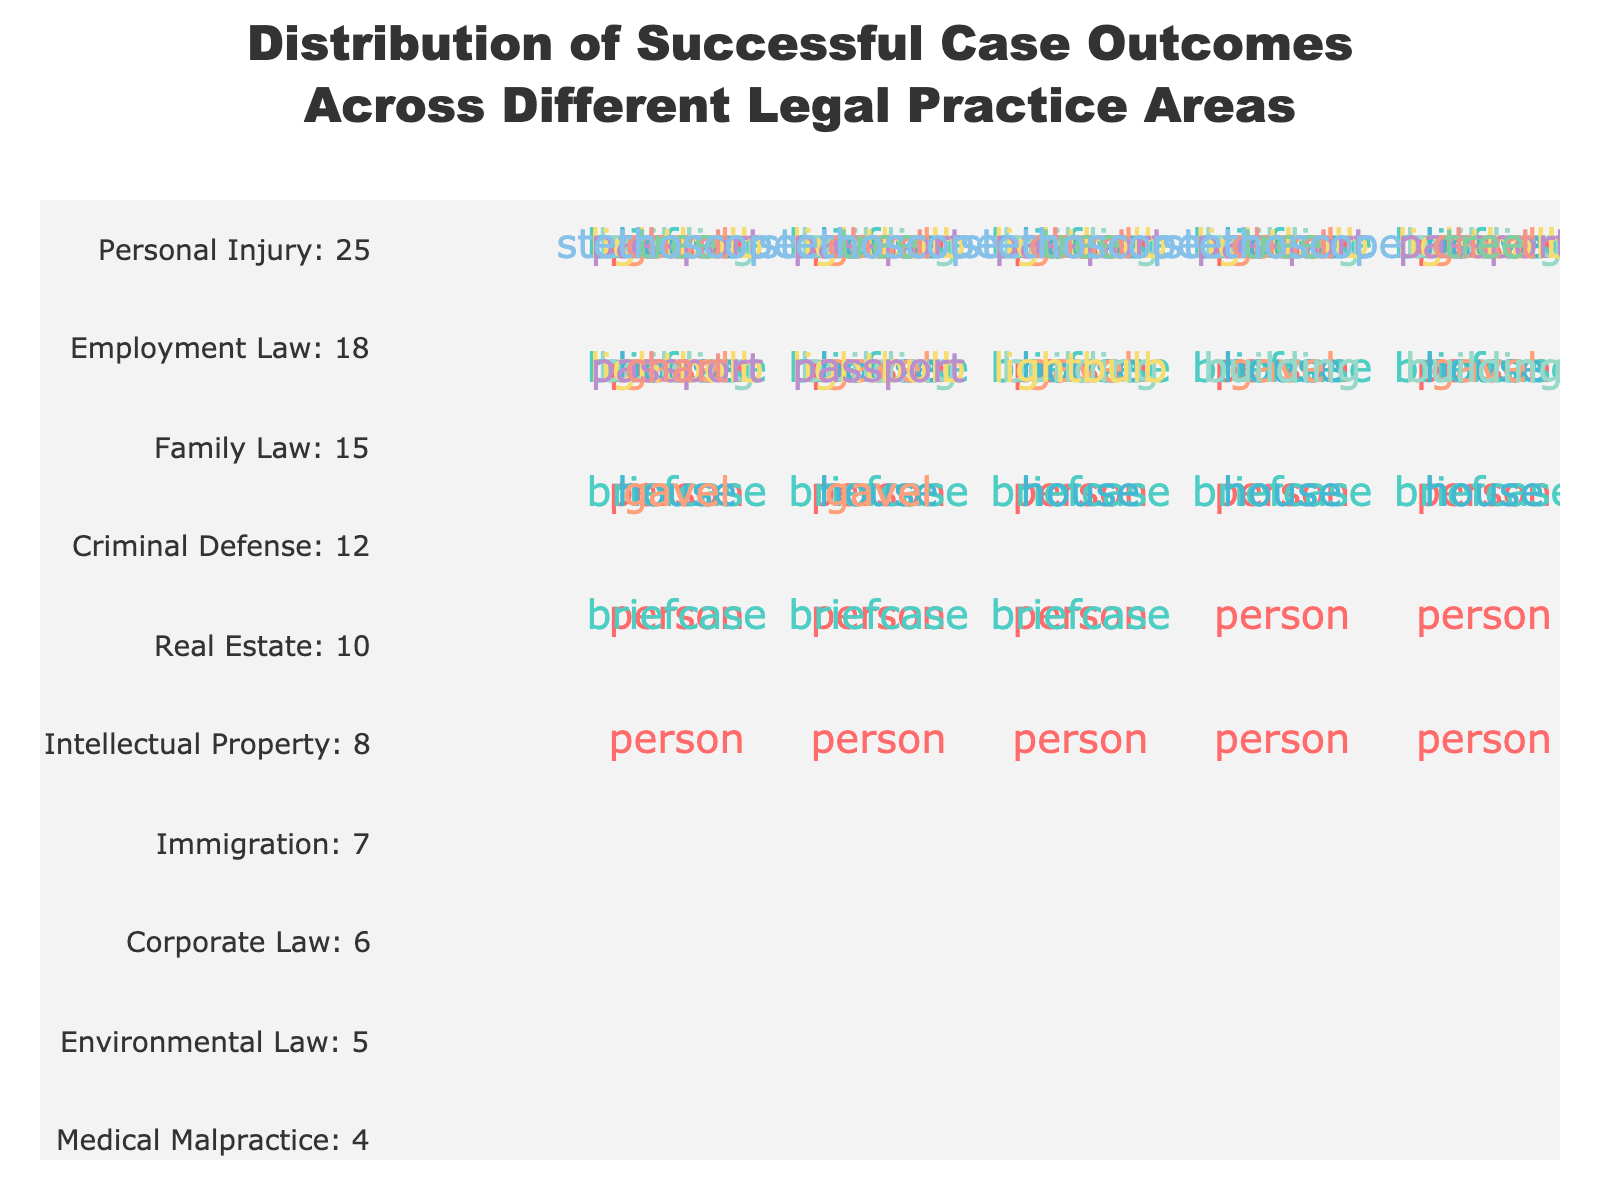What is the title of the plot? The title is centered at the top of the plot. It reads "Distribution of Successful Case Outcomes Across Different Legal Practice Areas".
Answer: Distribution of Successful Case Outcomes Across Different Legal Practice Areas Which legal practice area has the highest number of successful cases? The plot shows that the legal practice area with the most icons (persons) is "Personal Injury".
Answer: Personal Injury How many successful cases are there in Employment Law and Family Law combined? Employment Law has 18 successful cases and Family Law has 15 successful cases. Adding these together gives 18 + 15 = 33.
Answer: 33 Compare the number of successful cases in Criminal Defense and Immigration. Which one is higher? Criminal Defense has 12 successful cases and Immigration has 7 successful cases. Comparing these values, Criminal Defense has more successful cases.
Answer: Criminal Defense What icon represents Real Estate in the plot? The icon for Real Estate in the plot is shown as a building.
Answer: Building How many more successful cases does Personal Injury have compared to Medical Malpractice? Personal Injury has 25 successful cases, and Medical Malpractice has 4 successful cases. The difference between them is 25 - 4 = 21.
Answer: 21 What is the average number of successful cases across all legal practice areas? Add all successful cases: 25 (Personal Injury) + 18 (Employment Law) + 15 (Family Law) + 12 (Criminal Defense) + 10 (Real Estate) + 8 (Intellectual Property) + 7 (Immigration) + 6 (Corporate Law) + 5 (Environmental Law) + 4 (Medical Malpractice) = 110. There are 10 practice areas, so the average is 110 / 10 = 11.
Answer: 11 Identify the legal practice area with the third-highest number of successful cases. Personal Injury (25) is the highest, followed by Employment Law (18). The third-highest is Family Law with 15 successful cases.
Answer: Family Law Which practice areas have fewer than 10 successful cases? The practice areas with fewer than 10 successful cases are Intellectual Property (8), Immigration (7), Corporate Law (6), Environmental Law (5), and Medical Malpractice (4).
Answer: Intellectual Property, Immigration, Corporate Law, Environmental Law, Medical Malpractice What visual elements are used to indicate the number of successful cases for each practice area? The plot uses icons to represent the number of successful cases. Each practice area has a specific icon, and the number of icons corresponds to the number of successful cases.
Answer: Icons 